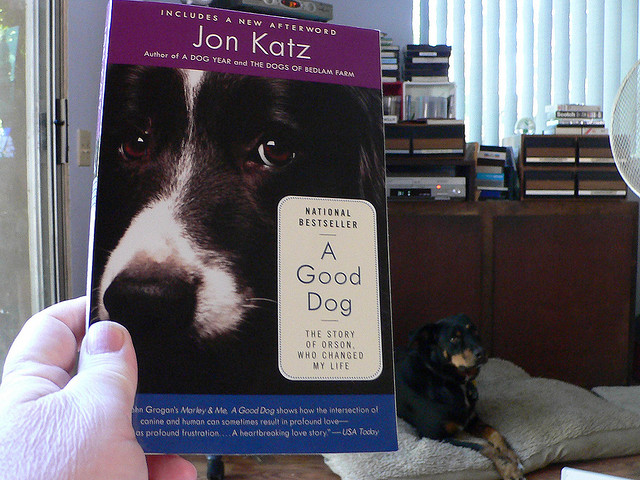What kind of atmosphere does this room convey? The room conveys a cozy and lived-in atmosphere. The presence of window blinds suggests natural light entering the space, and the dog's relaxed posture on the couch adds to the feeling of a peaceful and comfortable setting, perfect for reading or lounging. 